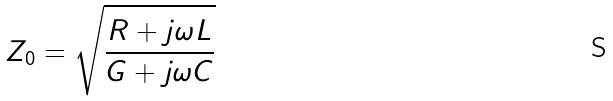Convert formula to latex. <formula><loc_0><loc_0><loc_500><loc_500>Z _ { 0 } = \sqrt { \frac { R + j \omega L } { G + j \omega C } }</formula> 